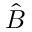<formula> <loc_0><loc_0><loc_500><loc_500>\hat { B }</formula> 